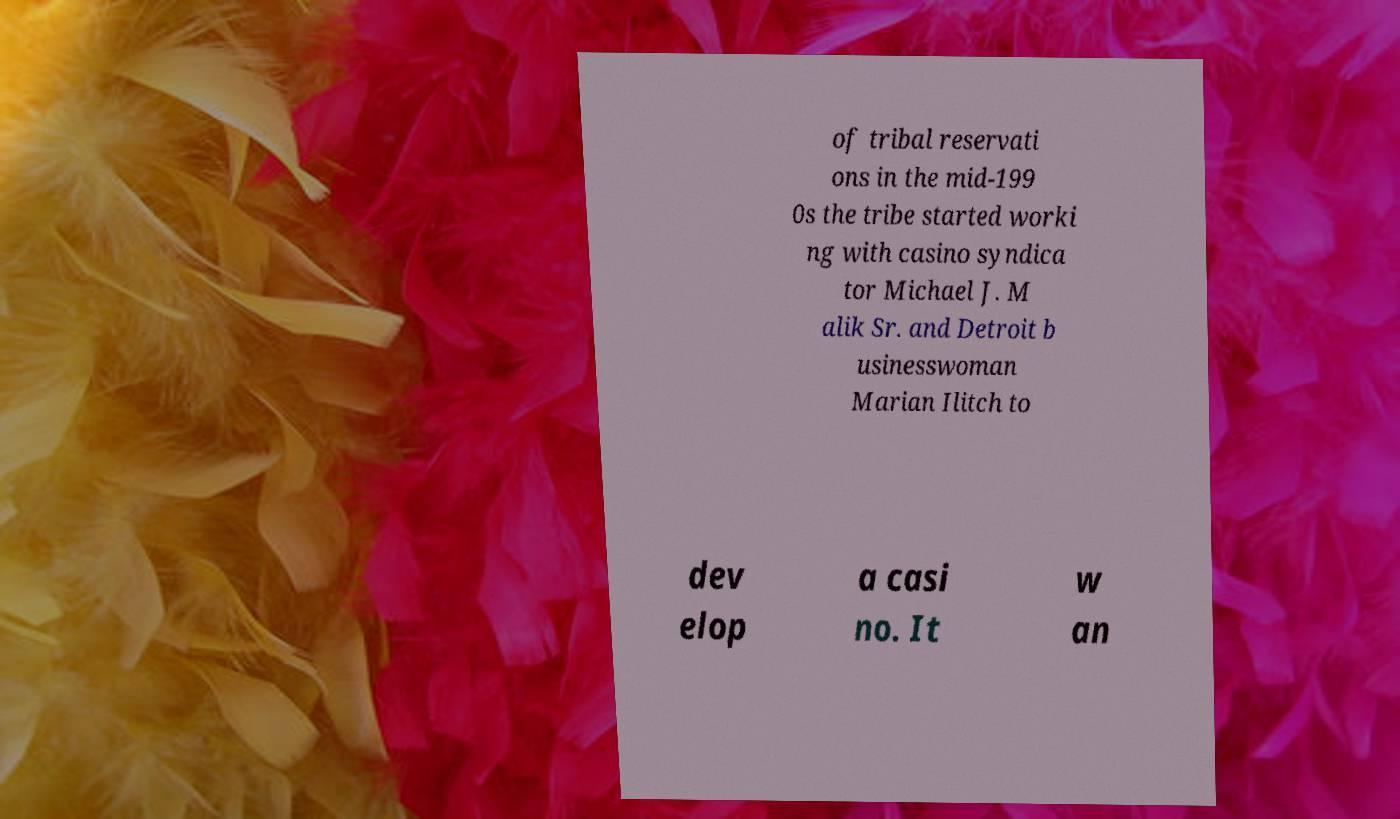Please identify and transcribe the text found in this image. of tribal reservati ons in the mid-199 0s the tribe started worki ng with casino syndica tor Michael J. M alik Sr. and Detroit b usinesswoman Marian Ilitch to dev elop a casi no. It w an 